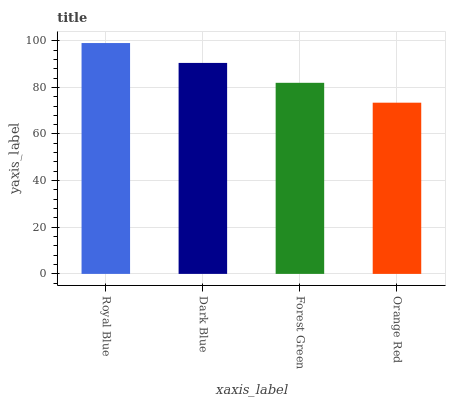Is Orange Red the minimum?
Answer yes or no. Yes. Is Royal Blue the maximum?
Answer yes or no. Yes. Is Dark Blue the minimum?
Answer yes or no. No. Is Dark Blue the maximum?
Answer yes or no. No. Is Royal Blue greater than Dark Blue?
Answer yes or no. Yes. Is Dark Blue less than Royal Blue?
Answer yes or no. Yes. Is Dark Blue greater than Royal Blue?
Answer yes or no. No. Is Royal Blue less than Dark Blue?
Answer yes or no. No. Is Dark Blue the high median?
Answer yes or no. Yes. Is Forest Green the low median?
Answer yes or no. Yes. Is Royal Blue the high median?
Answer yes or no. No. Is Dark Blue the low median?
Answer yes or no. No. 